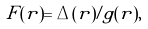<formula> <loc_0><loc_0><loc_500><loc_500>F ( { r } ) = \Delta ( { r } ) / g ( { r } ) ,</formula> 